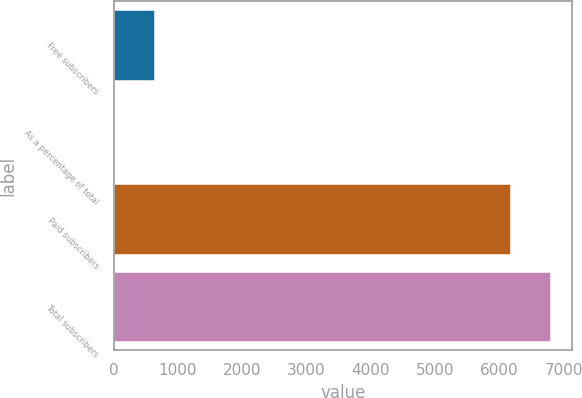Convert chart to OTSL. <chart><loc_0><loc_0><loc_500><loc_500><bar_chart><fcel>Free subscribers<fcel>As a percentage of total<fcel>Paid subscribers<fcel>Total subscribers<nl><fcel>633.94<fcel>2.6<fcel>6154<fcel>6785.34<nl></chart> 